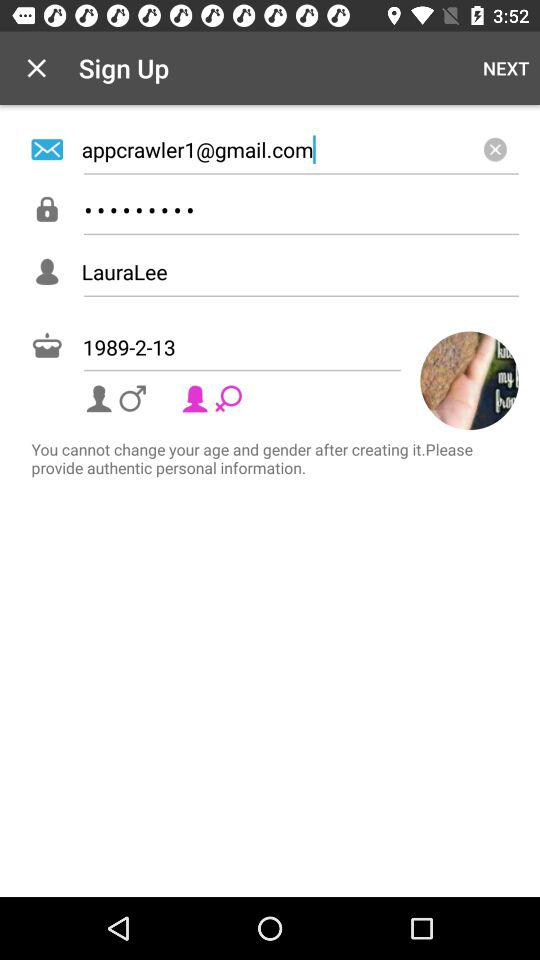What is the email address? The email address is appcrawler1@gmail.com. 